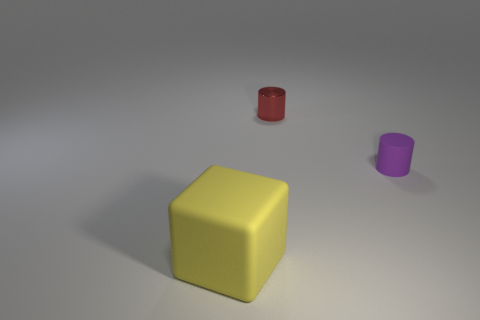Is the number of tiny matte things behind the tiny red shiny thing the same as the number of small purple rubber cylinders that are to the left of the rubber block?
Your answer should be very brief. Yes. How big is the rubber thing to the left of the rubber thing that is behind the big object?
Your answer should be very brief. Large. What is the material of the thing that is on the left side of the small purple matte object and in front of the tiny metallic cylinder?
Your answer should be very brief. Rubber. What number of other objects are the same size as the purple cylinder?
Keep it short and to the point. 1. The small rubber cylinder has what color?
Your answer should be compact. Purple. There is a small shiny object that is to the left of the purple thing; is its color the same as the rubber object that is in front of the purple matte thing?
Your answer should be compact. No. The red metallic cylinder has what size?
Offer a terse response. Small. There is a rubber object that is on the right side of the cube; what is its size?
Your answer should be compact. Small. There is a thing that is both behind the yellow block and in front of the small red metallic cylinder; what is its shape?
Your response must be concise. Cylinder. How many other objects are there of the same shape as the yellow object?
Ensure brevity in your answer.  0. 